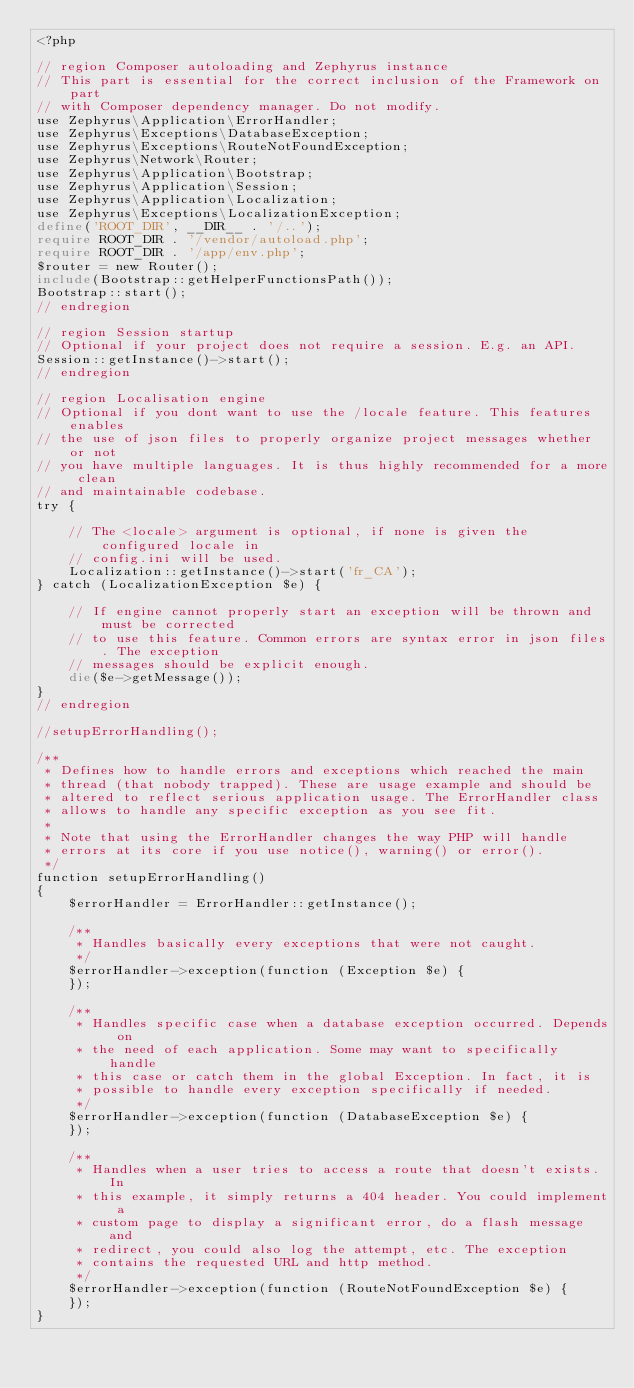Convert code to text. <code><loc_0><loc_0><loc_500><loc_500><_PHP_><?php

// region Composer autoloading and Zephyrus instance
// This part is essential for the correct inclusion of the Framework on part
// with Composer dependency manager. Do not modify.
use Zephyrus\Application\ErrorHandler;
use Zephyrus\Exceptions\DatabaseException;
use Zephyrus\Exceptions\RouteNotFoundException;
use Zephyrus\Network\Router;
use Zephyrus\Application\Bootstrap;
use Zephyrus\Application\Session;
use Zephyrus\Application\Localization;
use Zephyrus\Exceptions\LocalizationException;
define('ROOT_DIR', __DIR__ . '/..');
require ROOT_DIR . '/vendor/autoload.php';
require ROOT_DIR . '/app/env.php';
$router = new Router();
include(Bootstrap::getHelperFunctionsPath());
Bootstrap::start();
// endregion

// region Session startup
// Optional if your project does not require a session. E.g. an API.
Session::getInstance()->start();
// endregion

// region Localisation engine
// Optional if you dont want to use the /locale feature. This features enables
// the use of json files to properly organize project messages whether or not
// you have multiple languages. It is thus highly recommended for a more clean
// and maintainable codebase.
try {

    // The <locale> argument is optional, if none is given the configured locale in
    // config.ini will be used.
    Localization::getInstance()->start('fr_CA');
} catch (LocalizationException $e) {

    // If engine cannot properly start an exception will be thrown and must be corrected
    // to use this feature. Common errors are syntax error in json files. The exception
    // messages should be explicit enough.
    die($e->getMessage());
}
// endregion

//setupErrorHandling();

/**
 * Defines how to handle errors and exceptions which reached the main
 * thread (that nobody trapped). These are usage example and should be
 * altered to reflect serious application usage. The ErrorHandler class
 * allows to handle any specific exception as you see fit.
 *
 * Note that using the ErrorHandler changes the way PHP will handle
 * errors at its core if you use notice(), warning() or error().
 */
function setupErrorHandling()
{
    $errorHandler = ErrorHandler::getInstance();

    /**
     * Handles basically every exceptions that were not caught.
     */
    $errorHandler->exception(function (Exception $e) {
    });

    /**
     * Handles specific case when a database exception occurred. Depends on
     * the need of each application. Some may want to specifically handle
     * this case or catch them in the global Exception. In fact, it is
     * possible to handle every exception specifically if needed.
     */
    $errorHandler->exception(function (DatabaseException $e) {
    });

    /**
     * Handles when a user tries to access a route that doesn't exists. In
     * this example, it simply returns a 404 header. You could implement a
     * custom page to display a significant error, do a flash message and
     * redirect, you could also log the attempt, etc. The exception
     * contains the requested URL and http method.
     */
    $errorHandler->exception(function (RouteNotFoundException $e) {
    });
}</code> 